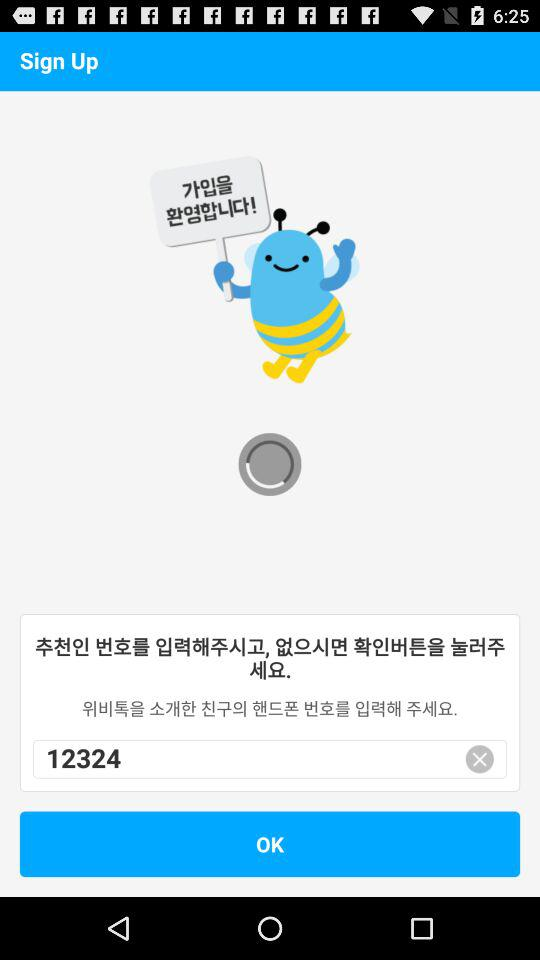Has the phone number been changed?
When the provided information is insufficient, respond with <no answer>. <no answer> 